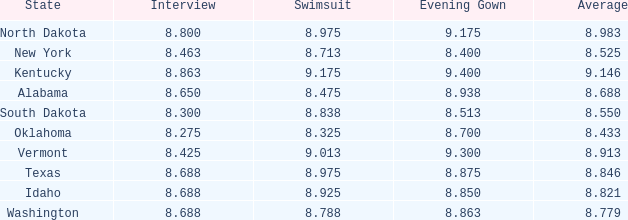Help me parse the entirety of this table. {'header': ['State', 'Interview', 'Swimsuit', 'Evening Gown', 'Average'], 'rows': [['North Dakota', '8.800', '8.975', '9.175', '8.983'], ['New York', '8.463', '8.713', '8.400', '8.525'], ['Kentucky', '8.863', '9.175', '9.400', '9.146'], ['Alabama', '8.650', '8.475', '8.938', '8.688'], ['South Dakota', '8.300', '8.838', '8.513', '8.550'], ['Oklahoma', '8.275', '8.325', '8.700', '8.433'], ['Vermont', '8.425', '9.013', '9.300', '8.913'], ['Texas', '8.688', '8.975', '8.875', '8.846'], ['Idaho', '8.688', '8.925', '8.850', '8.821'], ['Washington', '8.688', '8.788', '8.863', '8.779']]} What is the least evening rating of the contender with a formal dress less than None. 